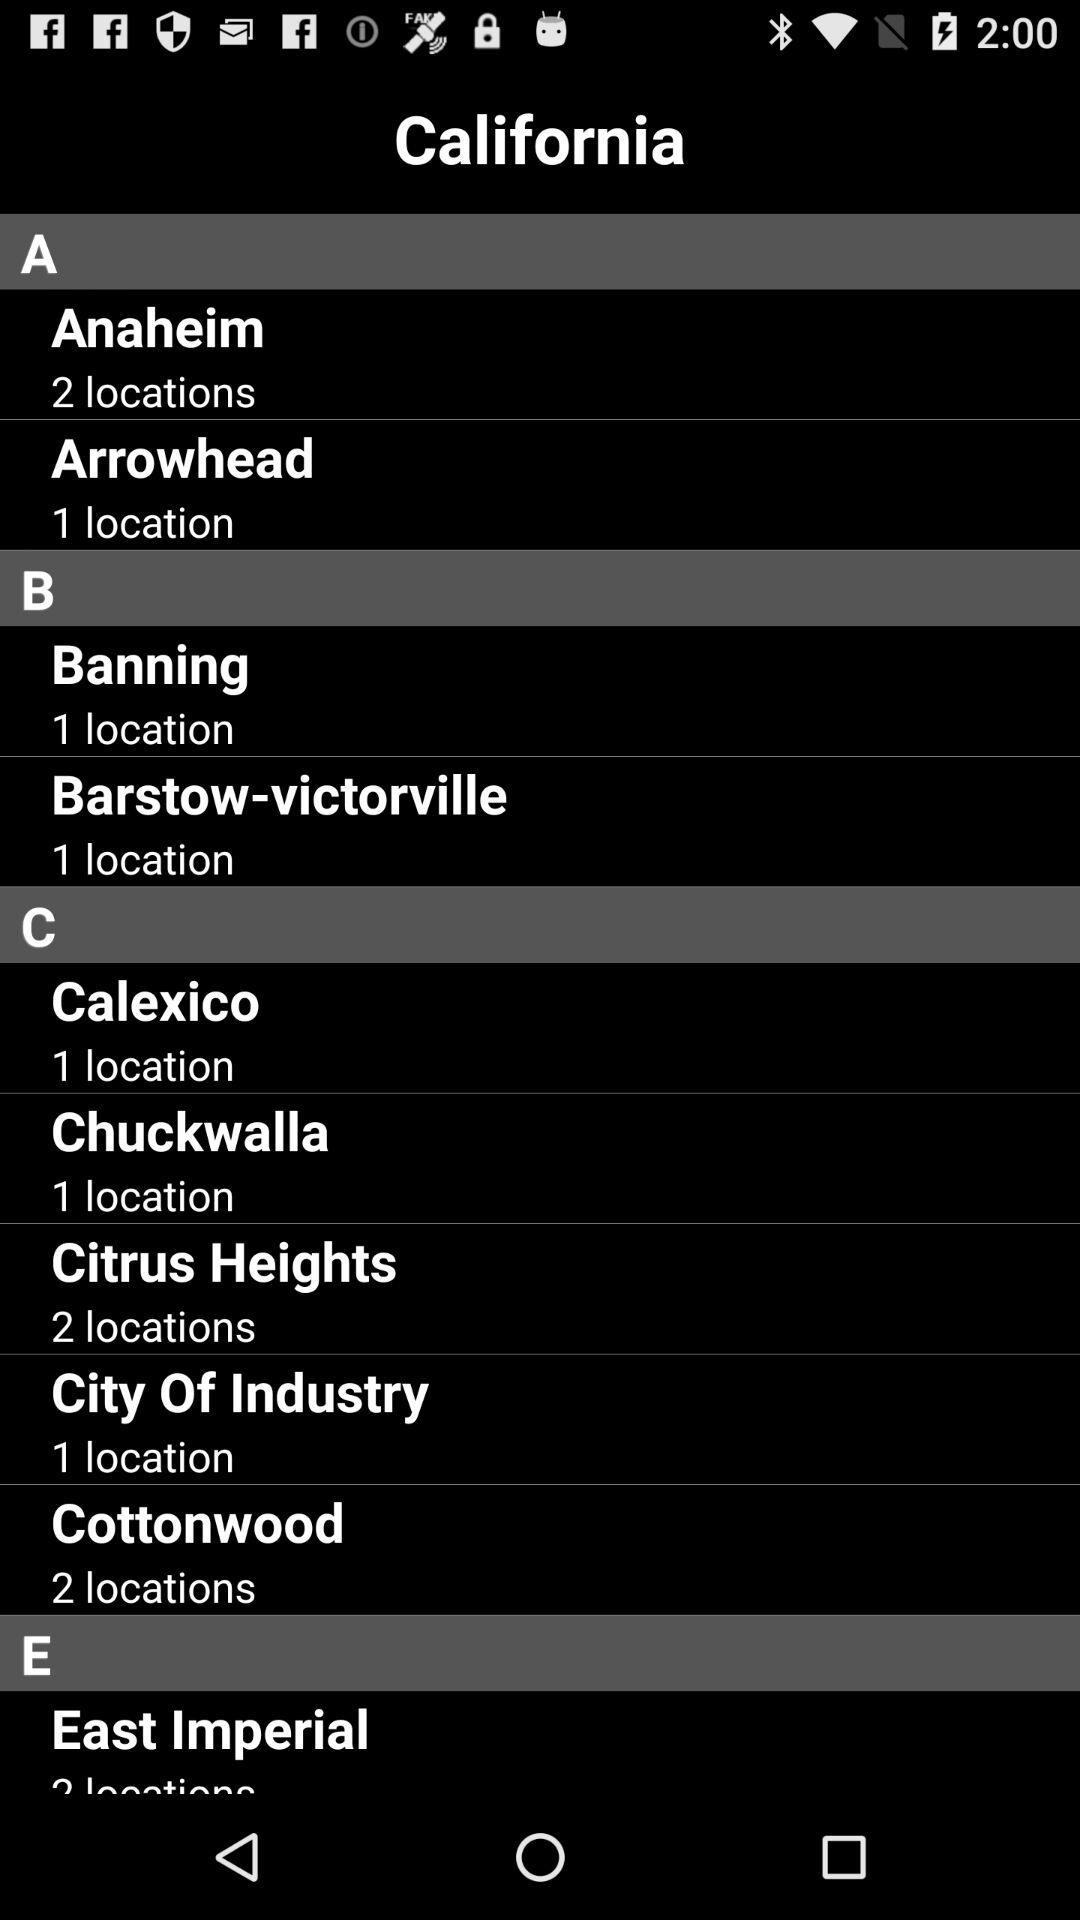How many locations are there in Cottonwood? There are 2 locations in Cottonwood. 